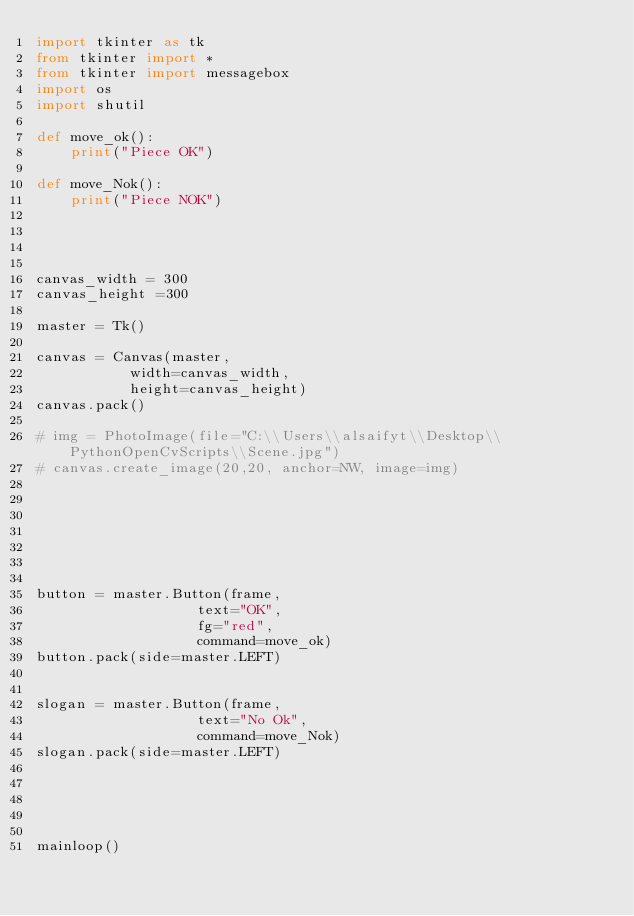<code> <loc_0><loc_0><loc_500><loc_500><_Python_>import tkinter as tk
from tkinter import *
from tkinter import messagebox   
import os
import shutil

def move_ok():
    print("Piece OK")

def move_Nok():
    print("Piece NOK")
    



canvas_width = 300
canvas_height =300

master = Tk()

canvas = Canvas(master, 
           width=canvas_width, 
           height=canvas_height)
canvas.pack()

# img = PhotoImage(file="C:\\Users\\alsaifyt\\Desktop\\PythonOpenCvScripts\\Scene.jpg")
# canvas.create_image(20,20, anchor=NW, image=img)







button = master.Button(frame, 
                   text="OK", 
                   fg="red",
                   command=move_ok)
button.pack(side=master.LEFT)


slogan = master.Button(frame,
                   text="No Ok",
                   command=move_Nok)
slogan.pack(side=master.LEFT)





mainloop()

















</code> 